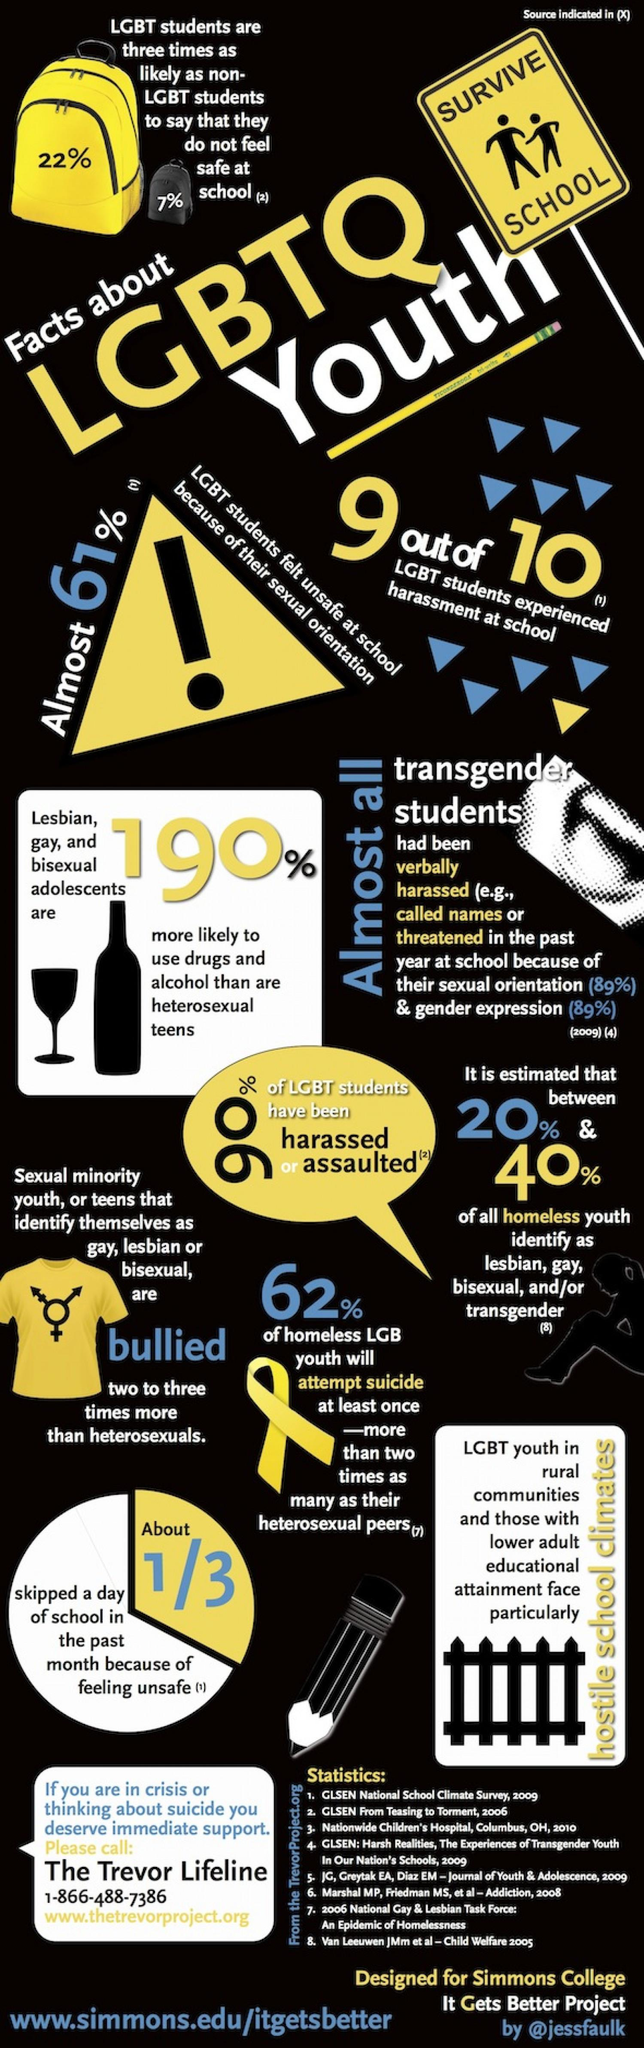Give some essential details in this illustration. According to a recent study, a staggering 62% of homeless LGB youth have attempted suicide. According to recent studies, a staggering 90% of LGBT students have experienced harassment or assault in schools. According to a recent study, 22% of LGBT students do not feel safe at school. According to a survey, 61% of LGBT students reported feeling unsafe at school due to their sexual orientation. According to a survey, only 7% of non-LGBT students feel safe at school. 